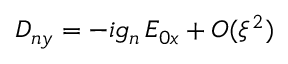Convert formula to latex. <formula><loc_0><loc_0><loc_500><loc_500>D _ { n y } = - i g _ { n } \, E _ { 0 x } + O ( \xi ^ { 2 } )</formula> 